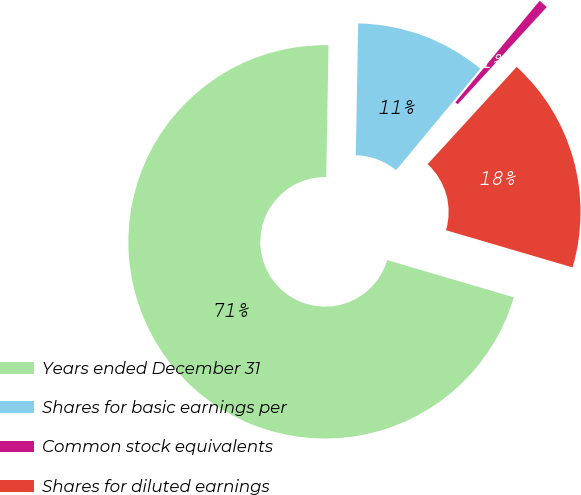Convert chart. <chart><loc_0><loc_0><loc_500><loc_500><pie_chart><fcel>Years ended December 31<fcel>Shares for basic earnings per<fcel>Common stock equivalents<fcel>Shares for diluted earnings<nl><fcel>70.73%<fcel>10.75%<fcel>0.77%<fcel>17.75%<nl></chart> 